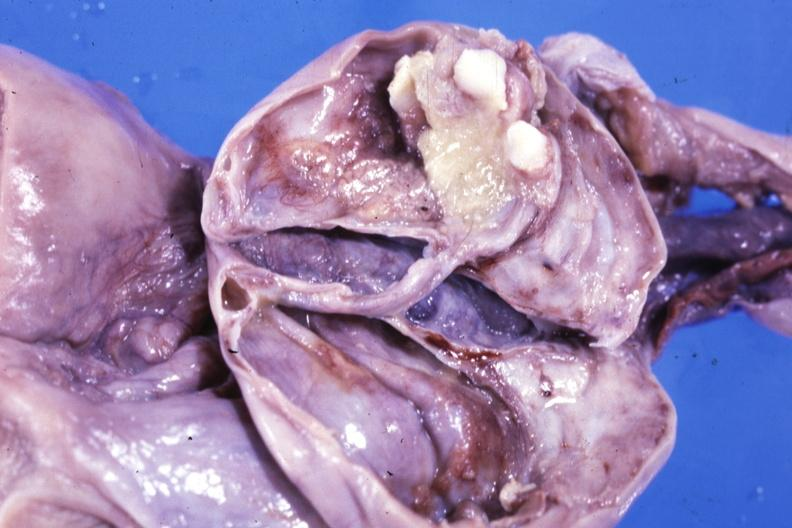s ovary present?
Answer the question using a single word or phrase. Yes 